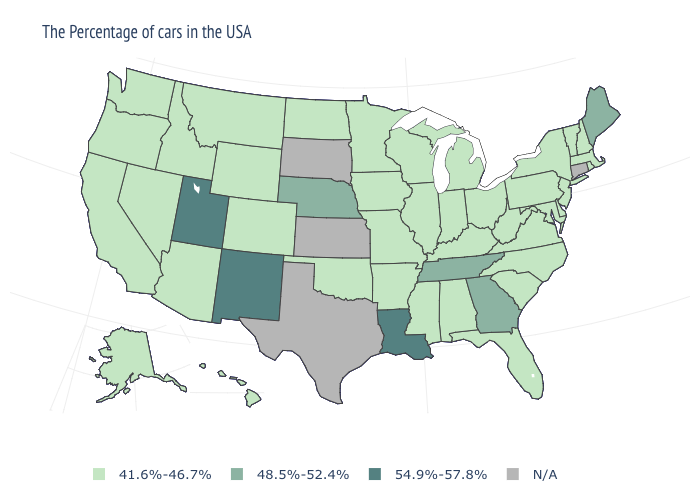Is the legend a continuous bar?
Be succinct. No. What is the value of Pennsylvania?
Give a very brief answer. 41.6%-46.7%. Which states have the lowest value in the USA?
Answer briefly. Massachusetts, Rhode Island, New Hampshire, Vermont, New York, New Jersey, Delaware, Maryland, Pennsylvania, Virginia, North Carolina, South Carolina, West Virginia, Ohio, Florida, Michigan, Kentucky, Indiana, Alabama, Wisconsin, Illinois, Mississippi, Missouri, Arkansas, Minnesota, Iowa, Oklahoma, North Dakota, Wyoming, Colorado, Montana, Arizona, Idaho, Nevada, California, Washington, Oregon, Alaska, Hawaii. Does Nebraska have the lowest value in the MidWest?
Give a very brief answer. No. What is the lowest value in the USA?
Give a very brief answer. 41.6%-46.7%. Name the states that have a value in the range 48.5%-52.4%?
Keep it brief. Maine, Georgia, Tennessee, Nebraska. What is the lowest value in the South?
Keep it brief. 41.6%-46.7%. Does Iowa have the highest value in the MidWest?
Give a very brief answer. No. What is the value of Iowa?
Be succinct. 41.6%-46.7%. What is the value of Nebraska?
Write a very short answer. 48.5%-52.4%. What is the highest value in states that border Wisconsin?
Give a very brief answer. 41.6%-46.7%. What is the value of Maryland?
Be succinct. 41.6%-46.7%. Which states have the highest value in the USA?
Keep it brief. Louisiana, New Mexico, Utah. What is the highest value in the USA?
Concise answer only. 54.9%-57.8%. 